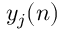<formula> <loc_0><loc_0><loc_500><loc_500>y _ { j } ( n )</formula> 